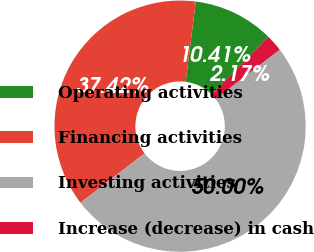Convert chart. <chart><loc_0><loc_0><loc_500><loc_500><pie_chart><fcel>Operating activities<fcel>Financing activities<fcel>Investing activities<fcel>Increase (decrease) in cash<nl><fcel>10.41%<fcel>37.42%<fcel>50.0%<fcel>2.17%<nl></chart> 